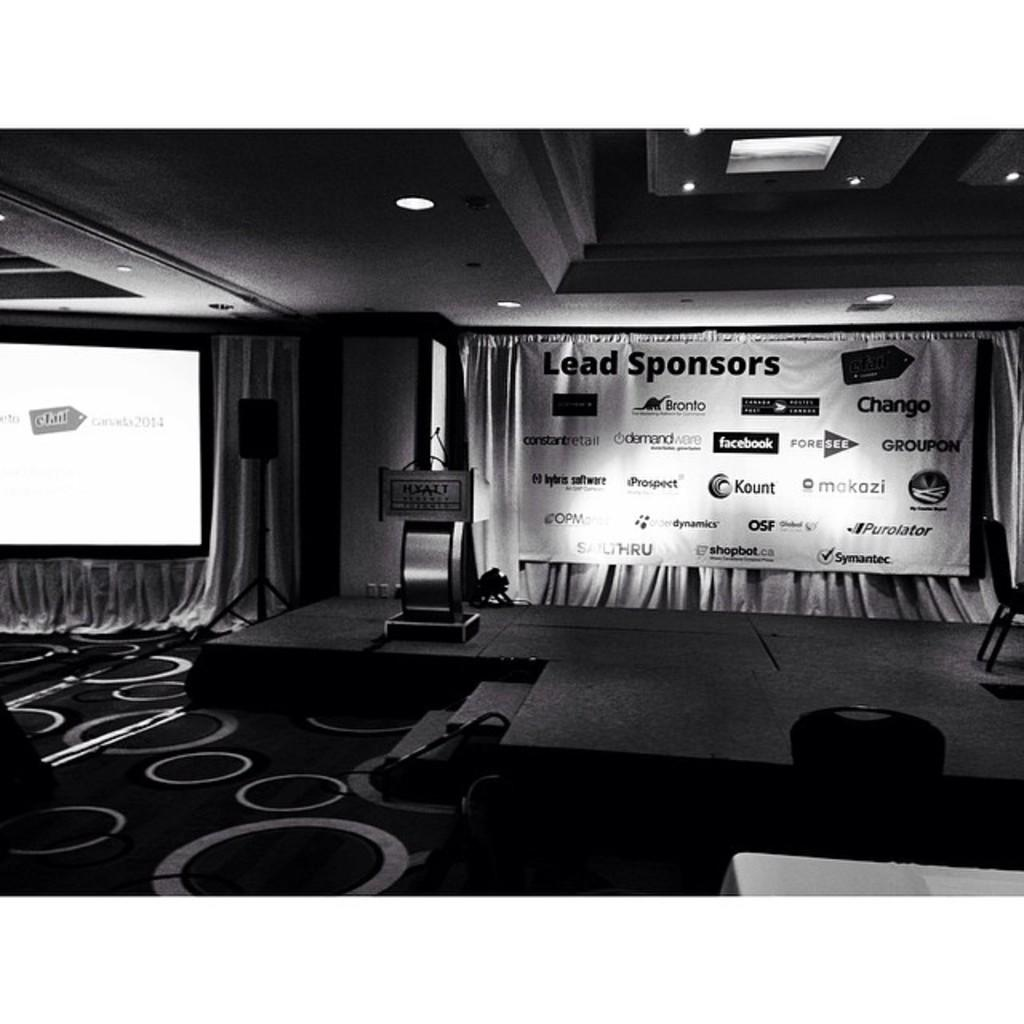What is located above the stage in the image? There is a chair and a podium above the stage in the image. What is in front of the stage? There are curtains, a hoarding, a screen, lights, a chair and table, and a speaker in front of the stage. Can you describe the lighting in the image? There are lights visible in the image. What type of wool is being used to make the camp in the image? There is no camp or wool present in the image. What town is depicted in the image? The image does not depict a town; it features a stage with various objects and lighting. 